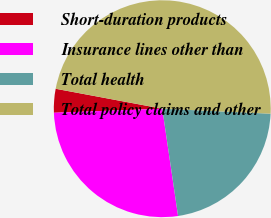<chart> <loc_0><loc_0><loc_500><loc_500><pie_chart><fcel>Short-duration products<fcel>Insurance lines other than<fcel>Total health<fcel>Total policy claims and other<nl><fcel>3.54%<fcel>26.73%<fcel>21.94%<fcel>47.79%<nl></chart> 